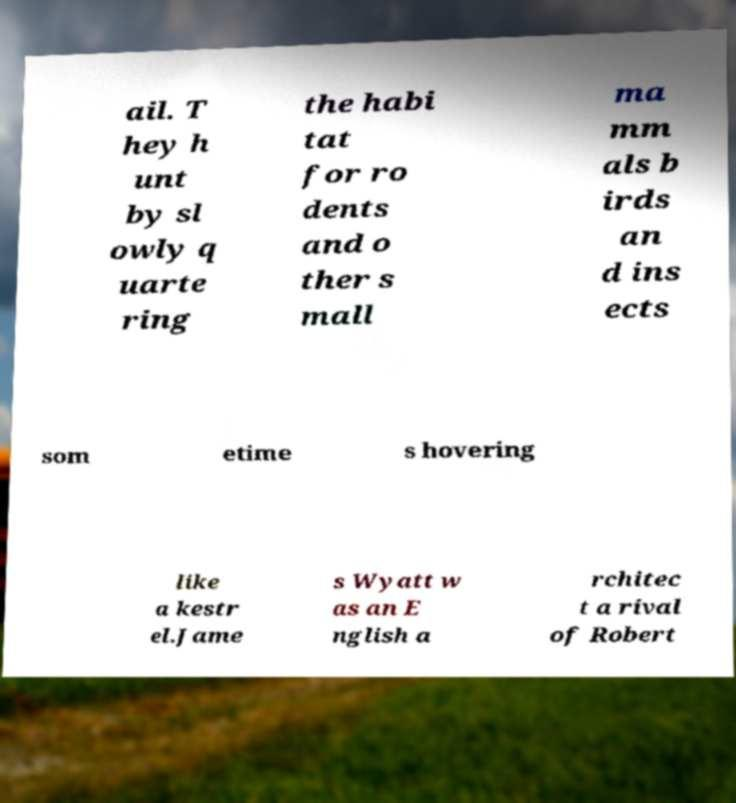Please read and relay the text visible in this image. What does it say? ail. T hey h unt by sl owly q uarte ring the habi tat for ro dents and o ther s mall ma mm als b irds an d ins ects som etime s hovering like a kestr el.Jame s Wyatt w as an E nglish a rchitec t a rival of Robert 